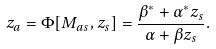Convert formula to latex. <formula><loc_0><loc_0><loc_500><loc_500>z _ { a } = \Phi [ M _ { a s } , z _ { s } ] = \frac { \beta ^ { \ast } + \alpha ^ { \ast } z _ { s } } { \alpha + \beta z _ { s } } .</formula> 